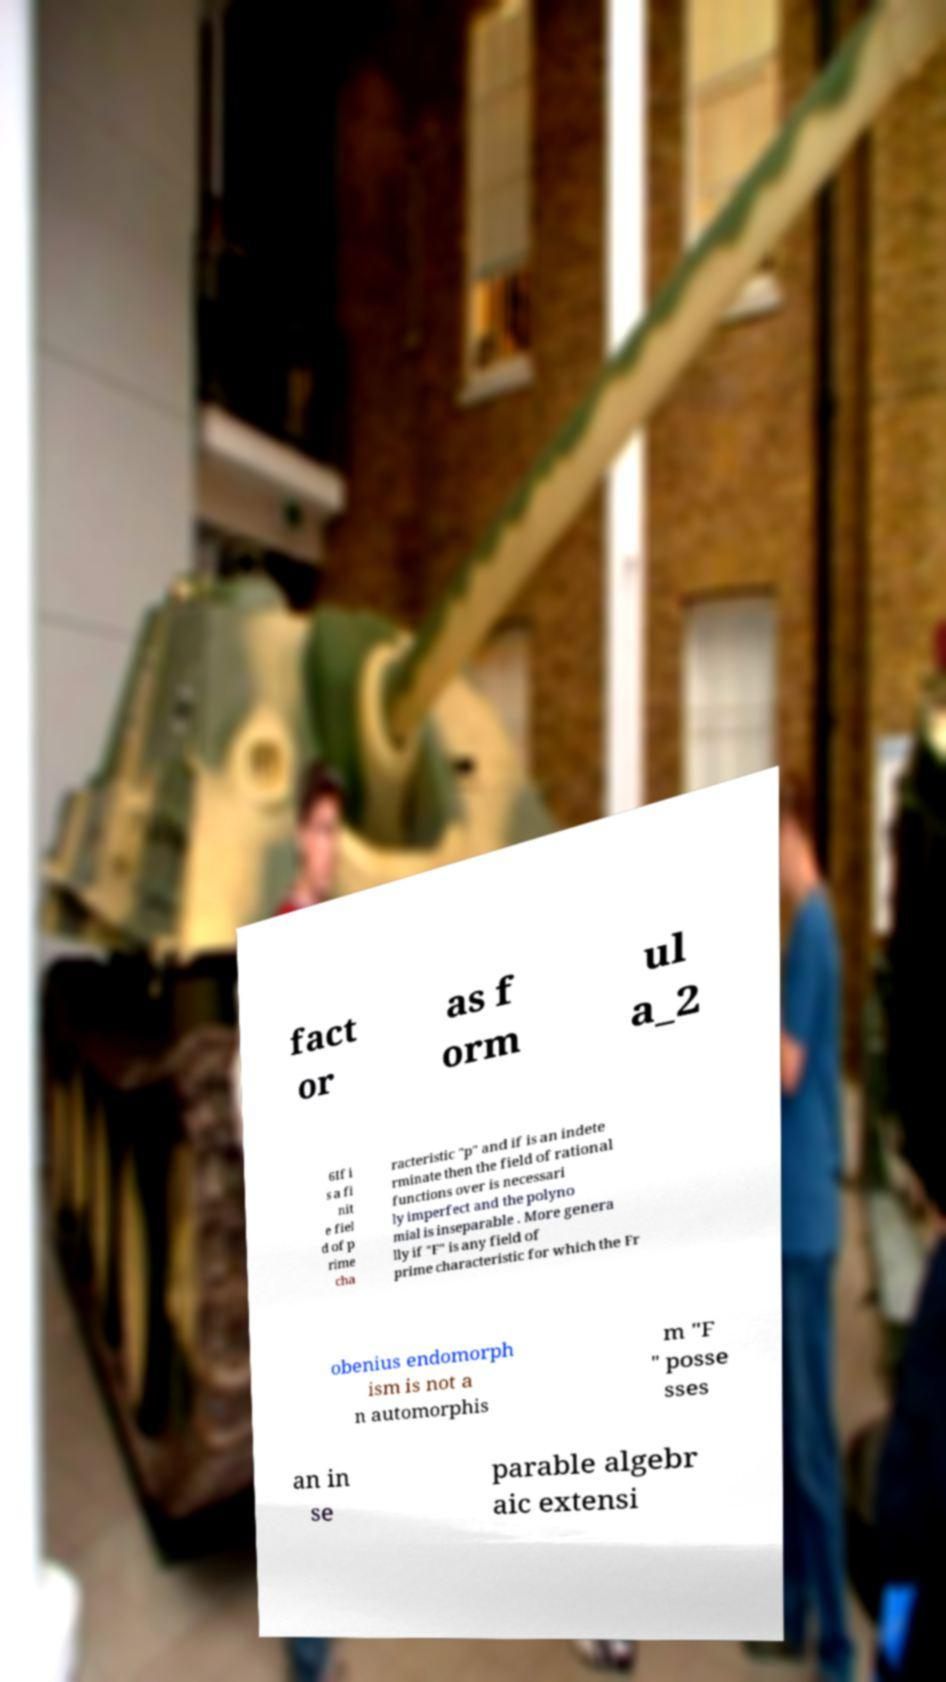Please identify and transcribe the text found in this image. fact or as f orm ul a_2 6If i s a fi nit e fiel d of p rime cha racteristic "p" and if is an indete rminate then the field of rational functions over is necessari ly imperfect and the polyno mial is inseparable . More genera lly if "F" is any field of prime characteristic for which the Fr obenius endomorph ism is not a n automorphis m "F " posse sses an in se parable algebr aic extensi 